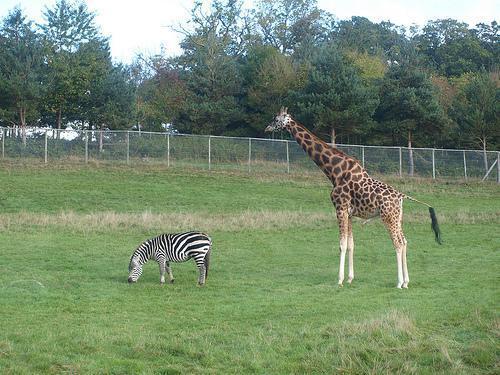How many animals are pictured?
Give a very brief answer. 2. How many zebra are there?
Give a very brief answer. 1. 